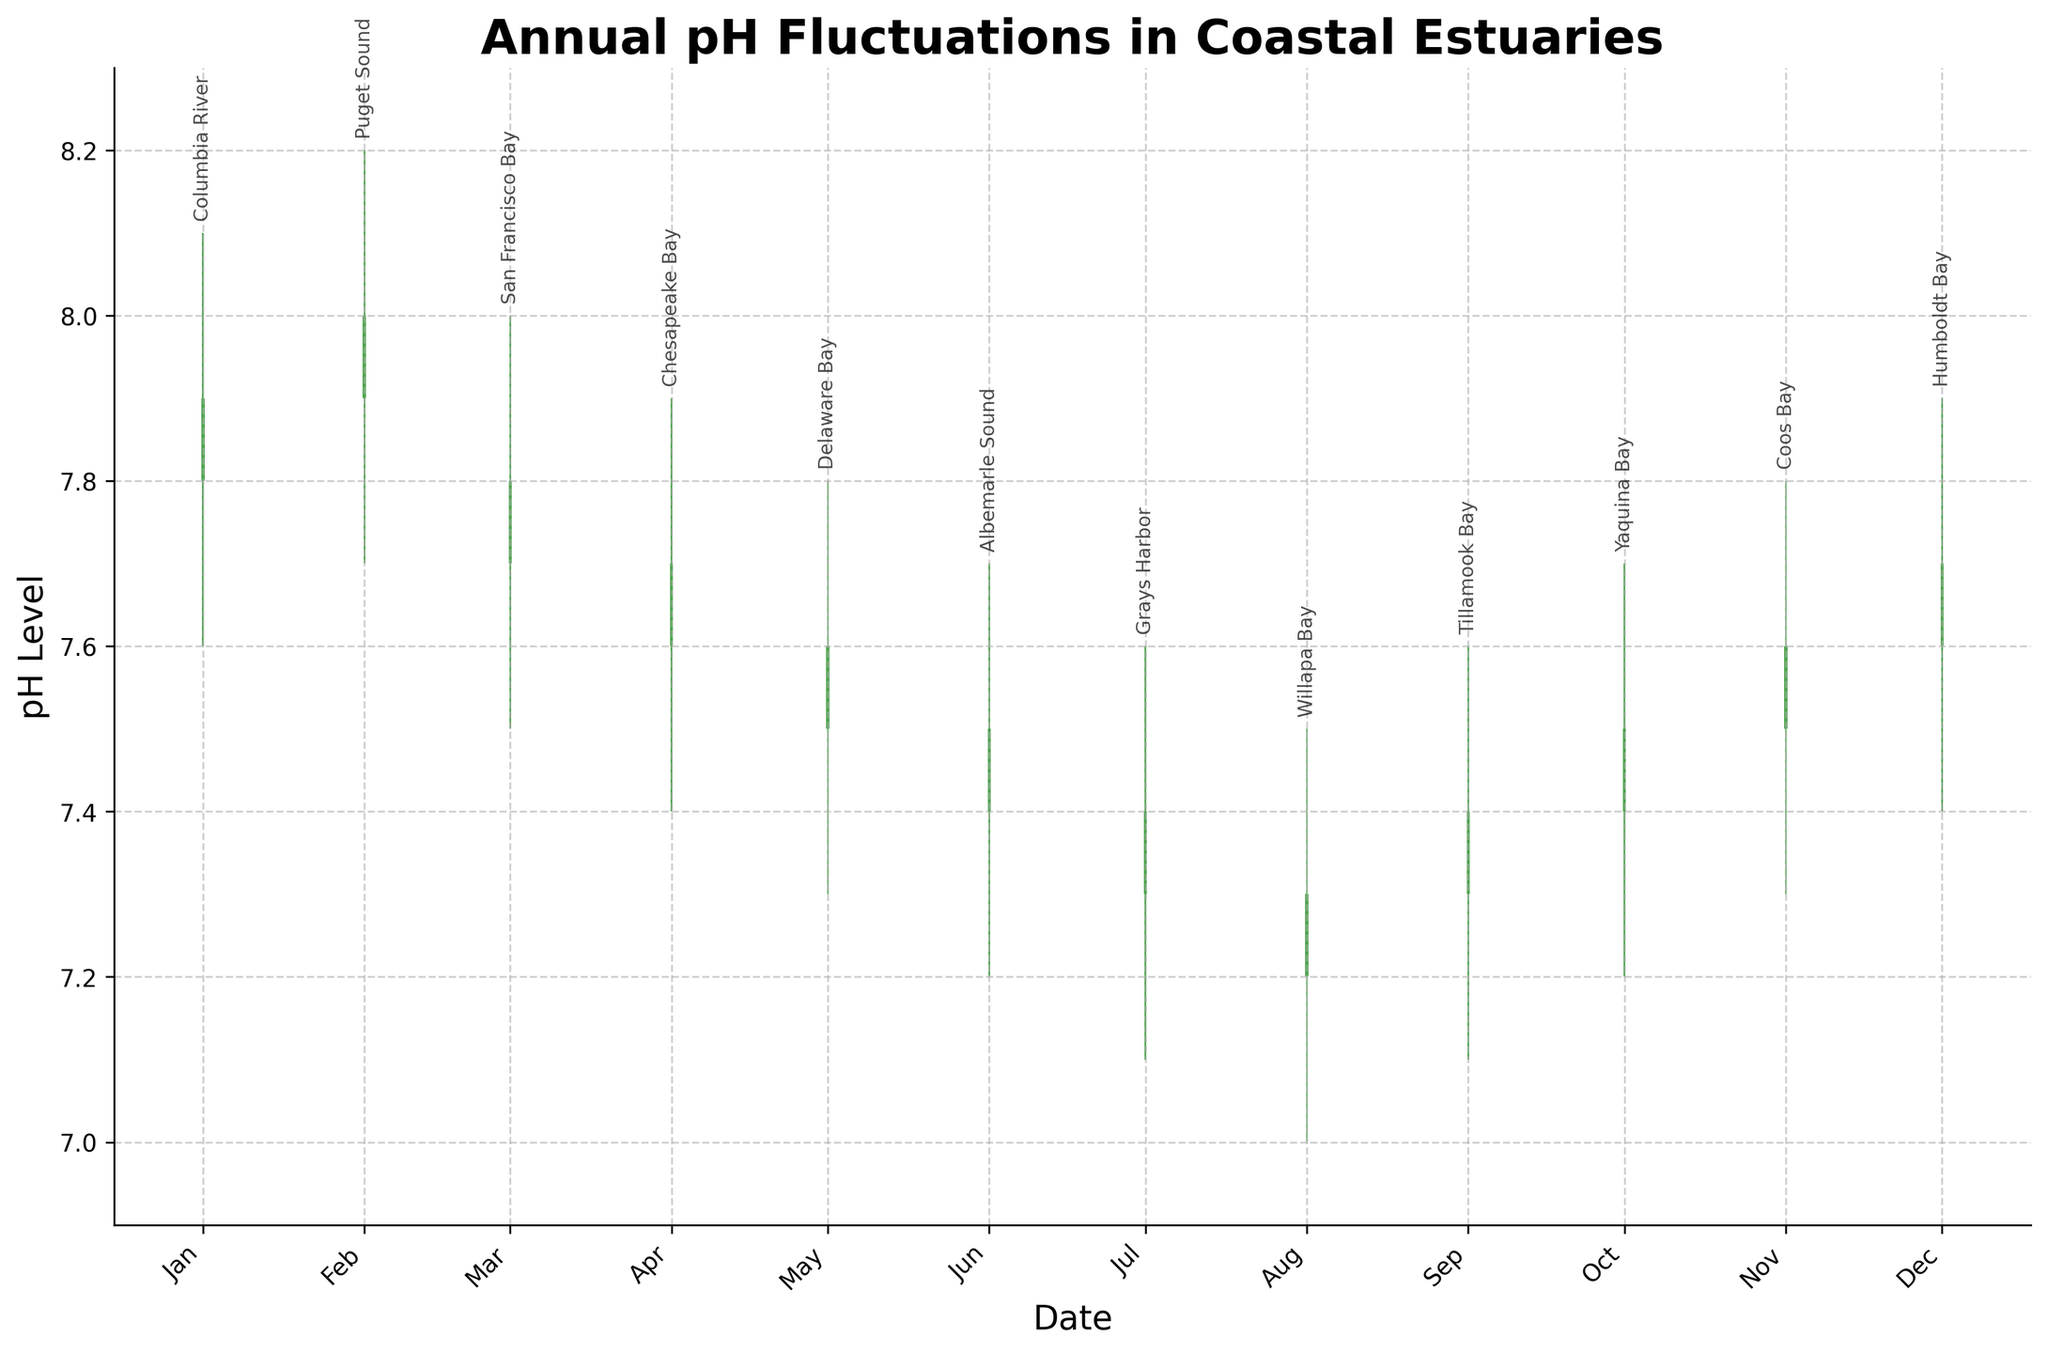What is the title of the plot? The title is located at the top center of the plot and reads "Annual pH Fluctuations in Coastal Estuaries".
Answer: Annual pH Fluctuations in Coastal Estuaries How many estuaries are represented in the plot? Each data point on the x-axis is labeled with a different estuary name, and each label corresponds to a distinct estuary.
Answer: 12 What month has the highest recorded pH level and what is that value? Look for the tallest green bar or line on the plot, indicating the highest recorded pH level. This occurs in February with a maximum pH of 8.2.
Answer: February, 8.2 What is the lowest Close pH value recorded in the year? Find the lowest point of the red bars or lines, indicating the lowest Close pH value recorded. This occurs in August with a value of 7.3.
Answer: August, 7.3 Which estuary has the highest range between its High and Low pH levels, and what is the range? Subtract the lowest pH value from the highest pH value for each month, and identify which estuary has the greatest difference. The Columbia River in January has the highest range with a difference of 0.5.
Answer: Columbia River, 0.5 Which month shows the greatest increase in Close pH value compared to the previous month? Compare the Close values month by month and identify which month has the largest increase from the prior month's Close value. From June, the value increased from 7.5 to 7.9 in January, showing the greatest increase of 0.4.
Answer: January, 0.4 Which months have a higher Close pH value compared to their Open pH value? Green bars indicate months where the Close pH value is higher than the Open pH value. These months are January, February, October, November, and December.
Answer: January, February, October, November, December In which month did the pH levels dip below 7.2? Look for months where the Low pH value is below 7.2. This happens in July and August, where the Low is 7.1 and 7.0 respectively.
Answer: July, August What is the average of the maximum pH values recorded (High values) across all months? Add up all the High pH values and divide by the number of months (12). The sum of the High values is 7.9 + 8.2 + 8.0 + 7.9 + 7.8 + 7.7 + 7.6 + 7.5 + 7.6 + 7.7 + 7.8 + 7.9 = 94.6. Dividing by 12 gives 94.6 / 12 = 7.883.
Answer: 7.883 